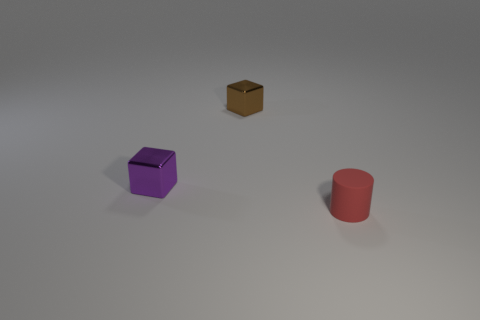Add 2 small green metallic objects. How many objects exist? 5 Subtract all purple blocks. How many blocks are left? 1 Subtract all red blocks. Subtract all green cylinders. How many blocks are left? 2 Subtract all cyan spheres. How many brown blocks are left? 1 Subtract all purple metal blocks. Subtract all red rubber cylinders. How many objects are left? 1 Add 3 purple blocks. How many purple blocks are left? 4 Add 2 big yellow metal cylinders. How many big yellow metal cylinders exist? 2 Subtract 0 cyan balls. How many objects are left? 3 Subtract all cubes. How many objects are left? 1 